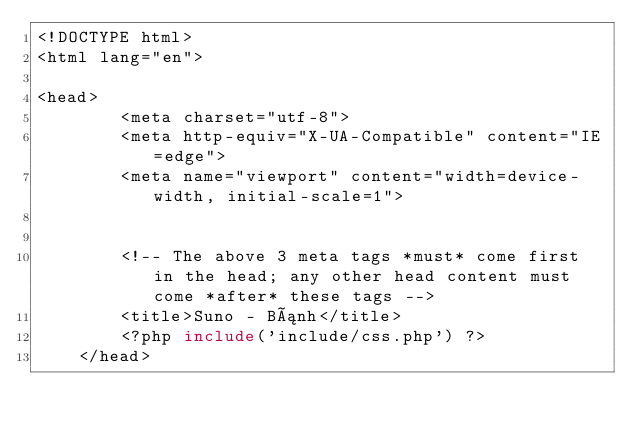<code> <loc_0><loc_0><loc_500><loc_500><_PHP_><!DOCTYPE html>
<html lang="en">
    
<head>
        <meta charset="utf-8">
        <meta http-equiv="X-UA-Compatible" content="IE=edge">
        <meta name="viewport" content="width=device-width, initial-scale=1">
        
        
        <!-- The above 3 meta tags *must* come first in the head; any other head content must come *after* these tags -->
        <title>Suno - Bánh</title>
        <?php include('include/css.php') ?>
    </head></code> 